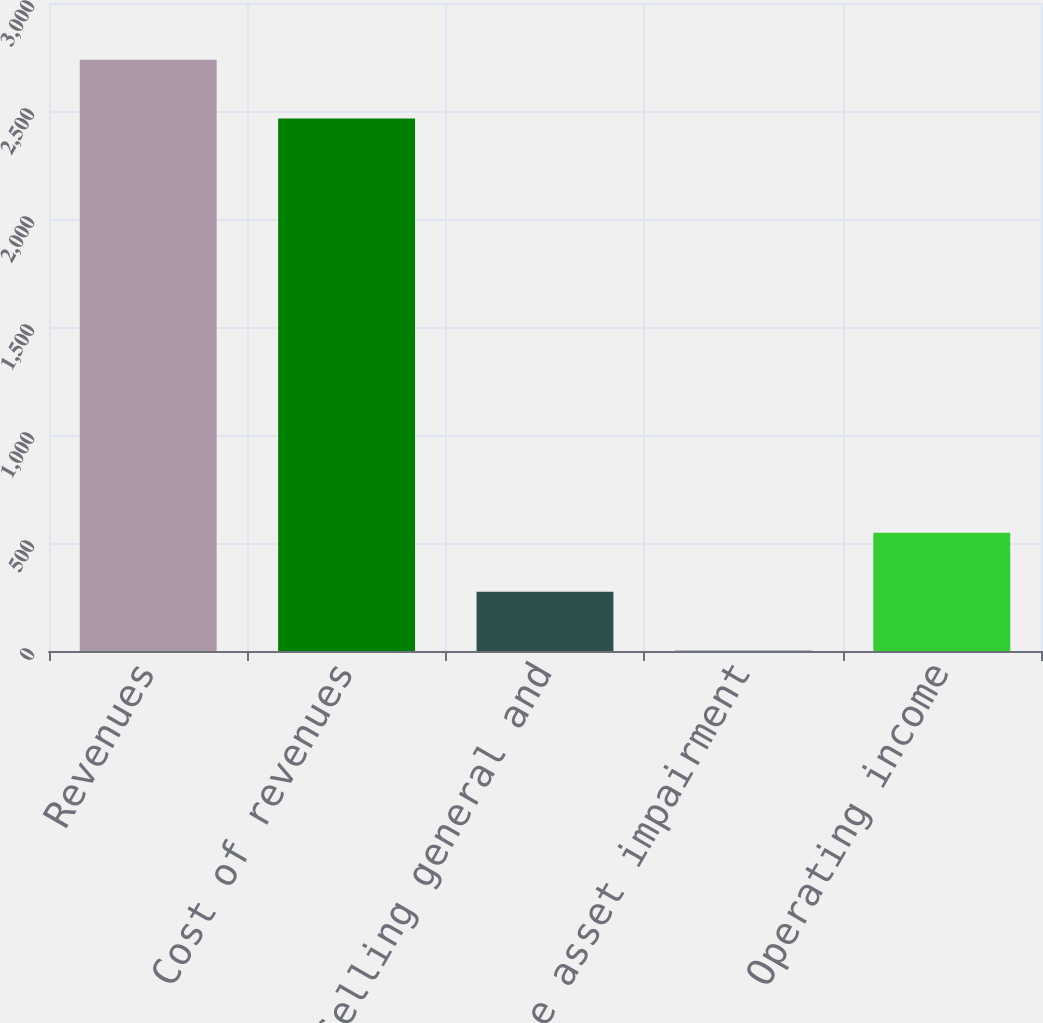Convert chart. <chart><loc_0><loc_0><loc_500><loc_500><bar_chart><fcel>Revenues<fcel>Cost of revenues<fcel>Selling general and<fcel>Intangible asset impairment<fcel>Operating income<nl><fcel>2737.6<fcel>2465<fcel>274.6<fcel>2<fcel>547.2<nl></chart> 